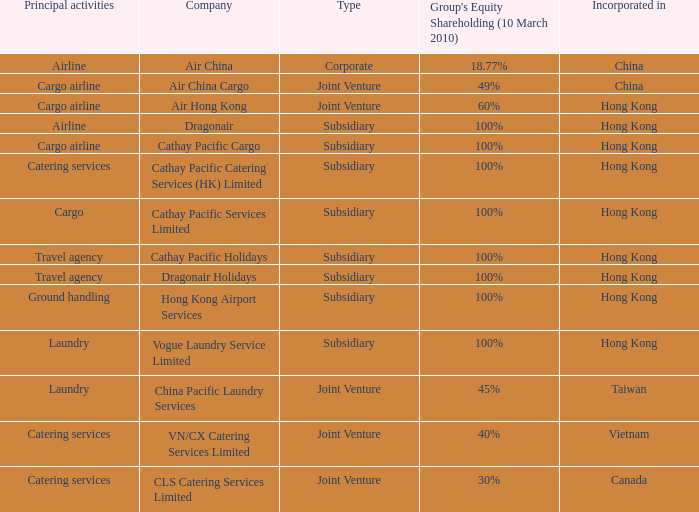What is the Group's equity share percentage for Company VN/CX catering services limited? 40%. 